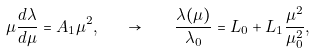<formula> <loc_0><loc_0><loc_500><loc_500>\mu \frac { d \lambda } { d \mu } = A _ { 1 } \mu ^ { 2 } , \quad \rightarrow \quad \frac { \lambda ( \mu ) } { \lambda _ { 0 } } = L _ { 0 } + L _ { 1 } \frac { \mu ^ { 2 } } { \mu _ { 0 } ^ { 2 } } ,</formula> 